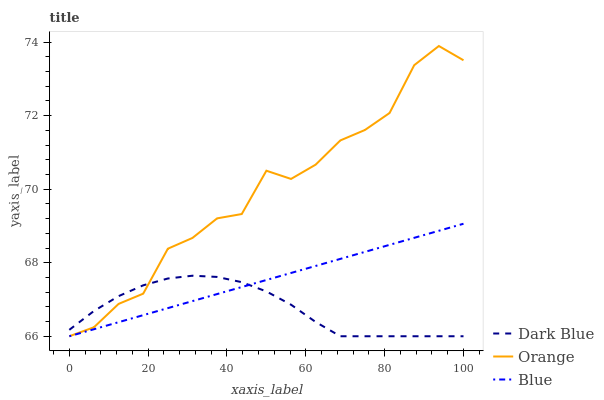Does Dark Blue have the minimum area under the curve?
Answer yes or no. Yes. Does Orange have the maximum area under the curve?
Answer yes or no. Yes. Does Blue have the minimum area under the curve?
Answer yes or no. No. Does Blue have the maximum area under the curve?
Answer yes or no. No. Is Blue the smoothest?
Answer yes or no. Yes. Is Orange the roughest?
Answer yes or no. Yes. Is Dark Blue the smoothest?
Answer yes or no. No. Is Dark Blue the roughest?
Answer yes or no. No. Does Orange have the lowest value?
Answer yes or no. Yes. Does Orange have the highest value?
Answer yes or no. Yes. Does Blue have the highest value?
Answer yes or no. No. Does Dark Blue intersect Orange?
Answer yes or no. Yes. Is Dark Blue less than Orange?
Answer yes or no. No. Is Dark Blue greater than Orange?
Answer yes or no. No. 